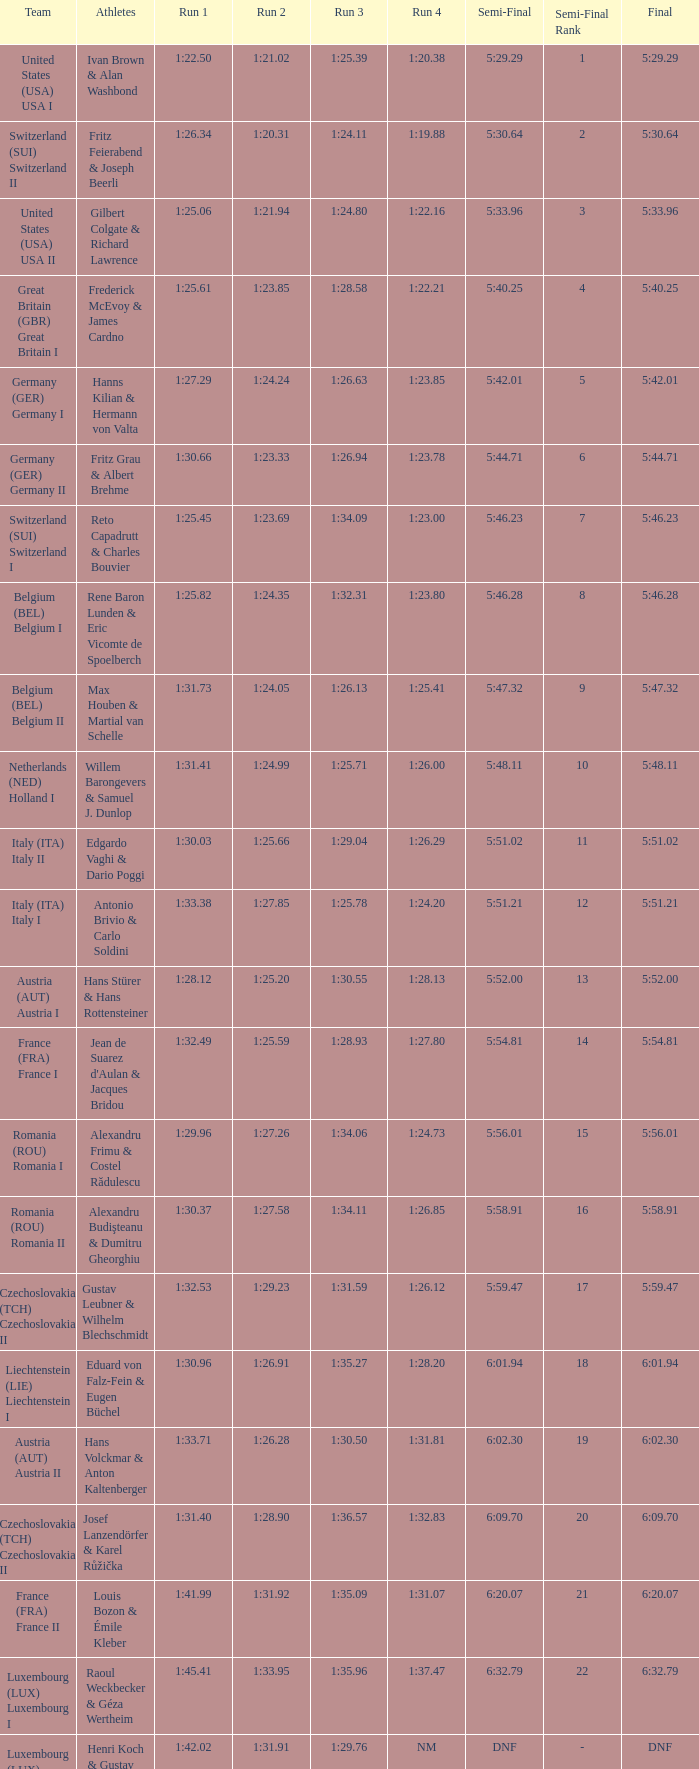Which Final has a Team of liechtenstein (lie) liechtenstein i? 6:01.94. Could you parse the entire table? {'header': ['Team', 'Athletes', 'Run 1', 'Run 2', 'Run 3', 'Run 4', 'Semi-Final', 'Semi-Final Rank', 'Final'], 'rows': [['United States (USA) USA I', 'Ivan Brown & Alan Washbond', '1:22.50', '1:21.02', '1:25.39', '1:20.38', '5:29.29', '1', '5:29.29'], ['Switzerland (SUI) Switzerland II', 'Fritz Feierabend & Joseph Beerli', '1:26.34', '1:20.31', '1:24.11', '1:19.88', '5:30.64', '2', '5:30.64'], ['United States (USA) USA II', 'Gilbert Colgate & Richard Lawrence', '1:25.06', '1:21.94', '1:24.80', '1:22.16', '5:33.96', '3', '5:33.96'], ['Great Britain (GBR) Great Britain I', 'Frederick McEvoy & James Cardno', '1:25.61', '1:23.85', '1:28.58', '1:22.21', '5:40.25', '4', '5:40.25'], ['Germany (GER) Germany I', 'Hanns Kilian & Hermann von Valta', '1:27.29', '1:24.24', '1:26.63', '1:23.85', '5:42.01', '5', '5:42.01'], ['Germany (GER) Germany II', 'Fritz Grau & Albert Brehme', '1:30.66', '1:23.33', '1:26.94', '1:23.78', '5:44.71', '6', '5:44.71'], ['Switzerland (SUI) Switzerland I', 'Reto Capadrutt & Charles Bouvier', '1:25.45', '1:23.69', '1:34.09', '1:23.00', '5:46.23', '7', '5:46.23'], ['Belgium (BEL) Belgium I', 'Rene Baron Lunden & Eric Vicomte de Spoelberch', '1:25.82', '1:24.35', '1:32.31', '1:23.80', '5:46.28', '8', '5:46.28'], ['Belgium (BEL) Belgium II', 'Max Houben & Martial van Schelle', '1:31.73', '1:24.05', '1:26.13', '1:25.41', '5:47.32', '9', '5:47.32'], ['Netherlands (NED) Holland I', 'Willem Barongevers & Samuel J. Dunlop', '1:31.41', '1:24.99', '1:25.71', '1:26.00', '5:48.11', '10', '5:48.11'], ['Italy (ITA) Italy II', 'Edgardo Vaghi & Dario Poggi', '1:30.03', '1:25.66', '1:29.04', '1:26.29', '5:51.02', '11', '5:51.02'], ['Italy (ITA) Italy I', 'Antonio Brivio & Carlo Soldini', '1:33.38', '1:27.85', '1:25.78', '1:24.20', '5:51.21', '12', '5:51.21'], ['Austria (AUT) Austria I', 'Hans Stürer & Hans Rottensteiner', '1:28.12', '1:25.20', '1:30.55', '1:28.13', '5:52.00', '13', '5:52.00'], ['France (FRA) France I', "Jean de Suarez d'Aulan & Jacques Bridou", '1:32.49', '1:25.59', '1:28.93', '1:27.80', '5:54.81', '14', '5:54.81'], ['Romania (ROU) Romania I', 'Alexandru Frimu & Costel Rădulescu', '1:29.96', '1:27.26', '1:34.06', '1:24.73', '5:56.01', '15', '5:56.01'], ['Romania (ROU) Romania II', 'Alexandru Budişteanu & Dumitru Gheorghiu', '1:30.37', '1:27.58', '1:34.11', '1:26.85', '5:58.91', '16', '5:58.91'], ['Czechoslovakia (TCH) Czechoslovakia II', 'Gustav Leubner & Wilhelm Blechschmidt', '1:32.53', '1:29.23', '1:31.59', '1:26.12', '5:59.47', '17', '5:59.47'], ['Liechtenstein (LIE) Liechtenstein I', 'Eduard von Falz-Fein & Eugen Büchel', '1:30.96', '1:26.91', '1:35.27', '1:28.20', '6:01.94', '18', '6:01.94'], ['Austria (AUT) Austria II', 'Hans Volckmar & Anton Kaltenberger', '1:33.71', '1:26.28', '1:30.50', '1:31.81', '6:02.30', '19', '6:02.30'], ['Czechoslovakia (TCH) Czechoslovakia II', 'Josef Lanzendörfer & Karel Růžička', '1:31.40', '1:28.90', '1:36.57', '1:32.83', '6:09.70', '20', '6:09.70'], ['France (FRA) France II', 'Louis Bozon & Émile Kleber', '1:41.99', '1:31.92', '1:35.09', '1:31.07', '6:20.07', '21', '6:20.07'], ['Luxembourg (LUX) Luxembourg I', 'Raoul Weckbecker & Géza Wertheim', '1:45.41', '1:33.95', '1:35.96', '1:37.47', '6:32.79', '22', '6:32.79'], ['Luxembourg (LUX) Luxembourg II', 'Henri Koch & Gustav Wagner', '1:42.02', '1:31.91', '1:29.76', 'NM', 'DNF', '-', 'DNF']]} 